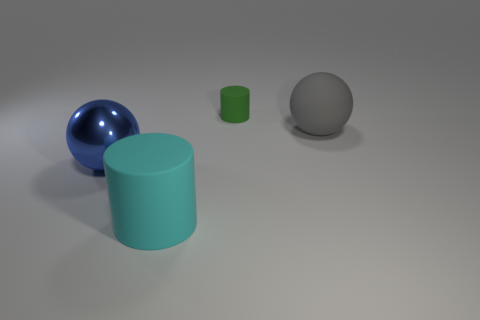Add 3 gray matte spheres. How many objects exist? 7 Add 1 large blue balls. How many large blue balls are left? 2 Add 4 metal cubes. How many metal cubes exist? 4 Subtract 0 gray cubes. How many objects are left? 4 Subtract all tiny green matte objects. Subtract all blue spheres. How many objects are left? 2 